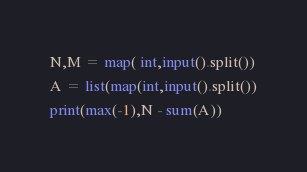Convert code to text. <code><loc_0><loc_0><loc_500><loc_500><_Python_>N,M = map( int,input().split())
A = list(map(int,input().split())
print(max(-1),N - sum(A))</code> 